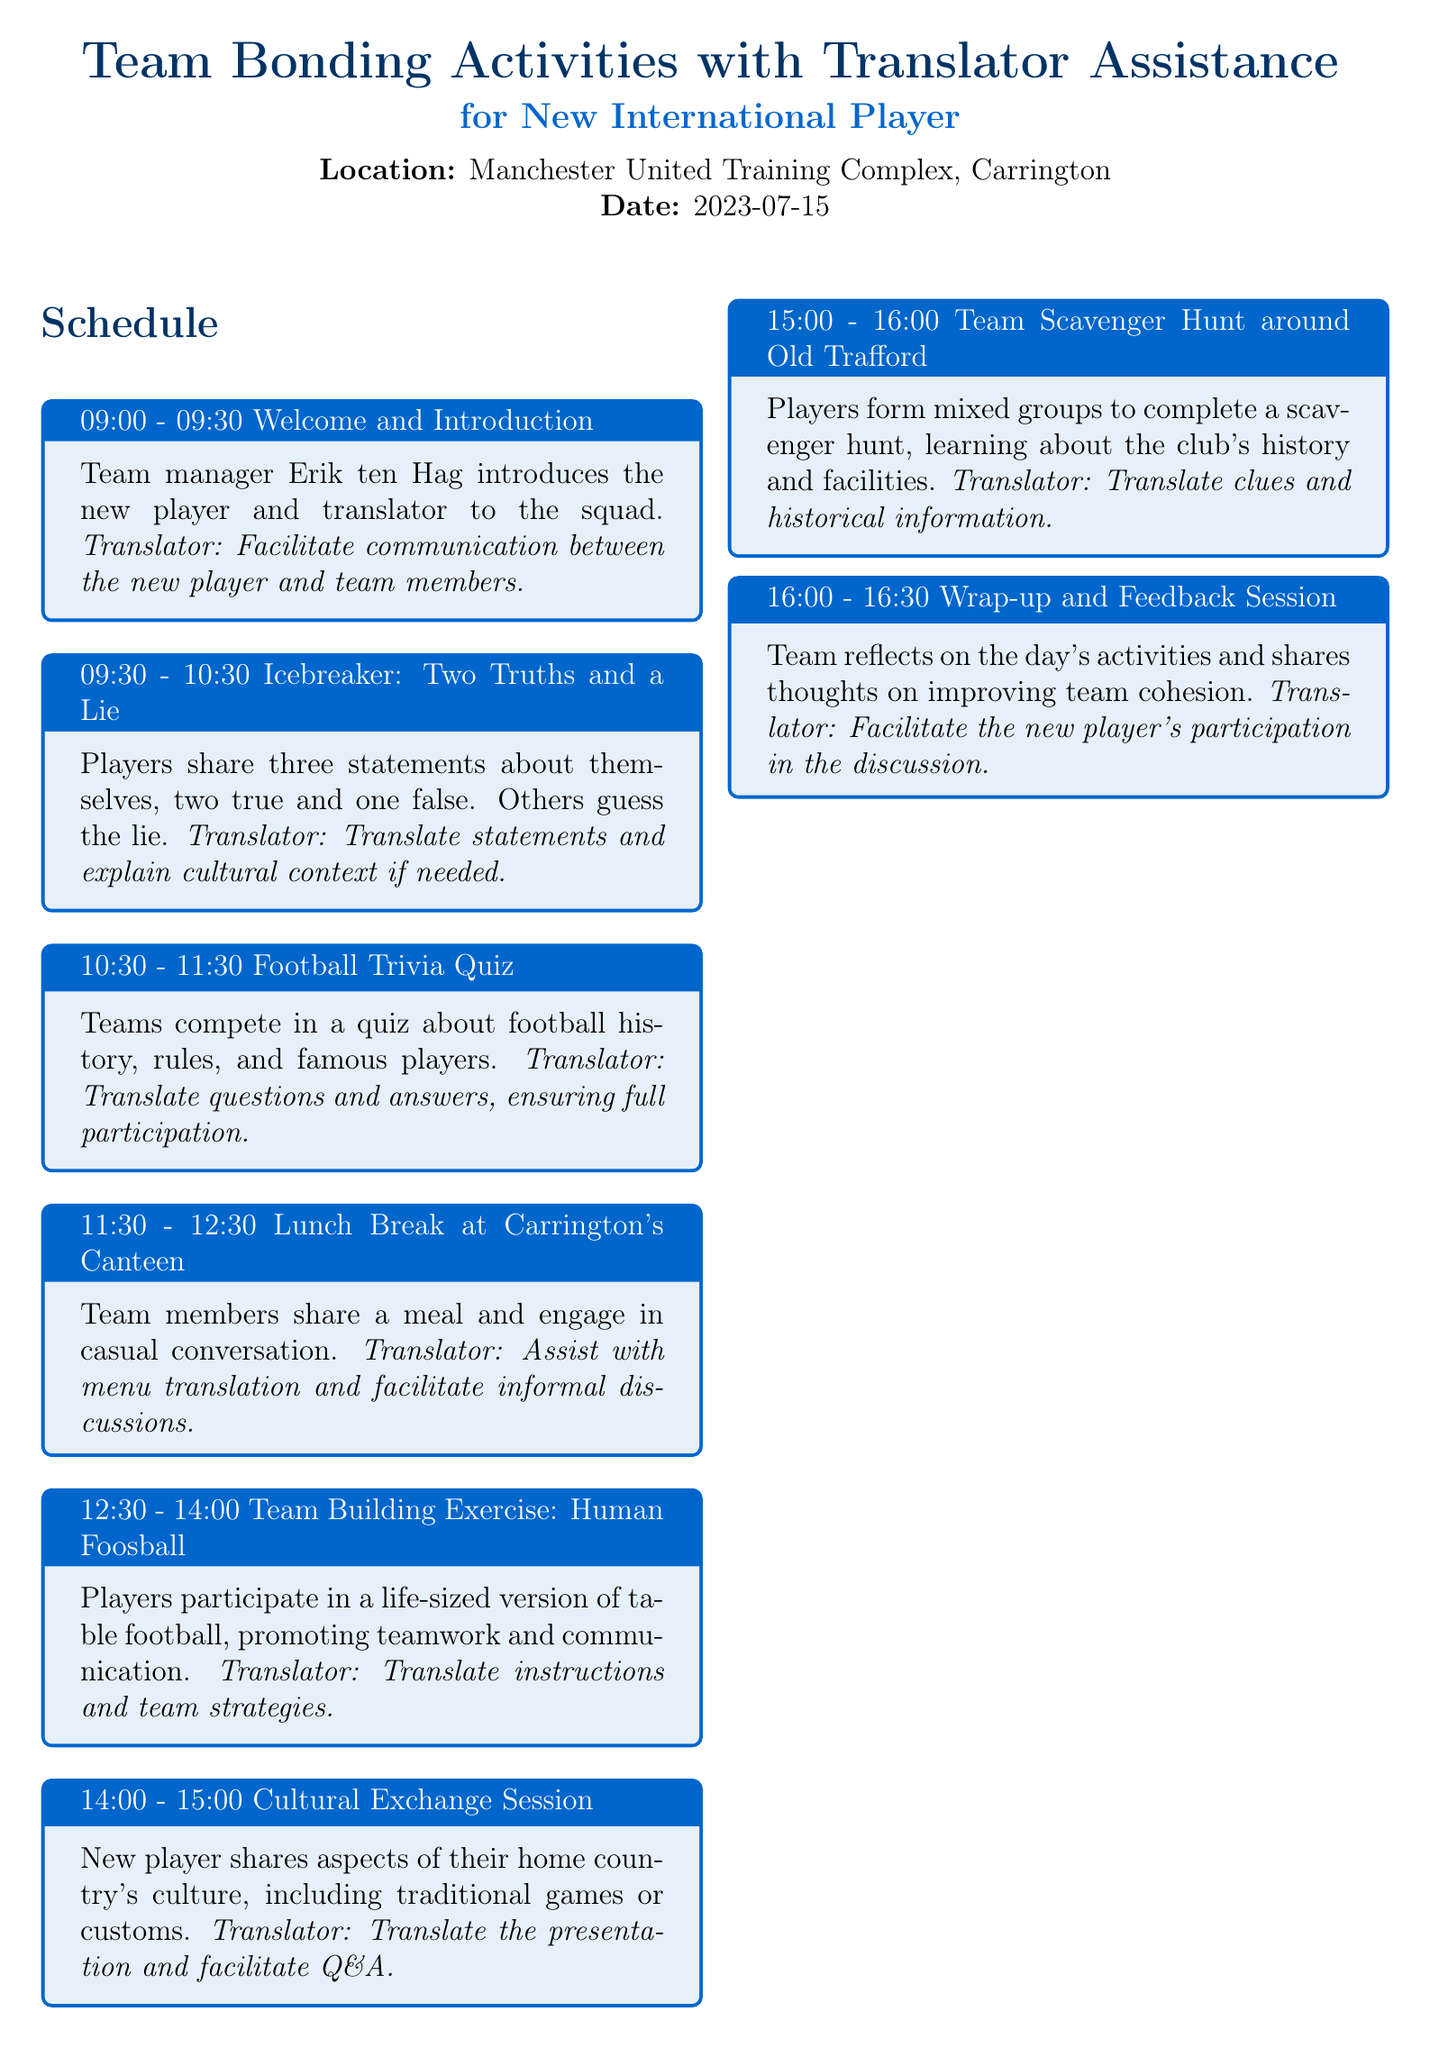What is the date of the activities? The date is mentioned at the beginning of the document as 2023-07-15.
Answer: 2023-07-15 Where will the activities take place? The location is provided in the document under the location section as Manchester United Training Complex, Carrington.
Answer: Manchester United Training Complex, Carrington Who introduces the new player to the squad? The document specifies that the team manager Erik ten Hag introduces the new player and translator to the squad during the Welcome and Introduction activity.
Answer: Erik ten Hag What is the first activity on the agenda? The first activity listed in the schedule is Welcome and Introduction.
Answer: Welcome and Introduction How long is the lunch break scheduled for? The lunch break is mentioned in the agenda with a specific time duration from 11:30 to 12:30, which is 1 hour.
Answer: 1 hour What activity involves teamwork and communication through play? The document describes the Team Building Exercise: Human Foosball as promoting teamwork and communication.
Answer: Human Foosball Who will assist with menu translation during the lunch break? The document indicates that the translator will assist with menu translation during the lunch break.
Answer: Translator What is one additional note mentioned in the agenda? The document lists several additional notes, one being that all written materials should be available in both English and the new player's native language.
Answer: Ensure all written materials are available in both English and the new player's native language 